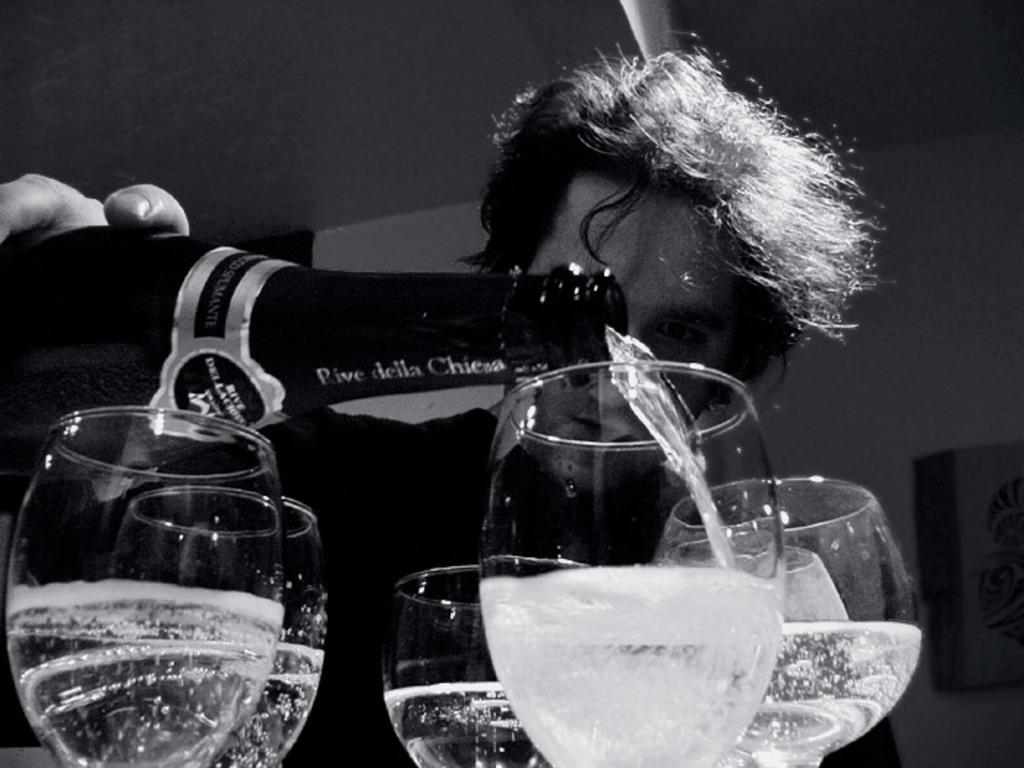How many glasses of wine are visible in the image? There are six glasses of wine in the image. What is the person in the image doing with the bottle? The person is holding a bottle and pouring wine into one of the glasses. What can be seen in the background of the image? There is a wall in the background of the image. What arithmetic problem is being solved by the glasses of wine in the image? There is no arithmetic problem being solved by the glasses of wine in the image; they are simply glasses of wine. 